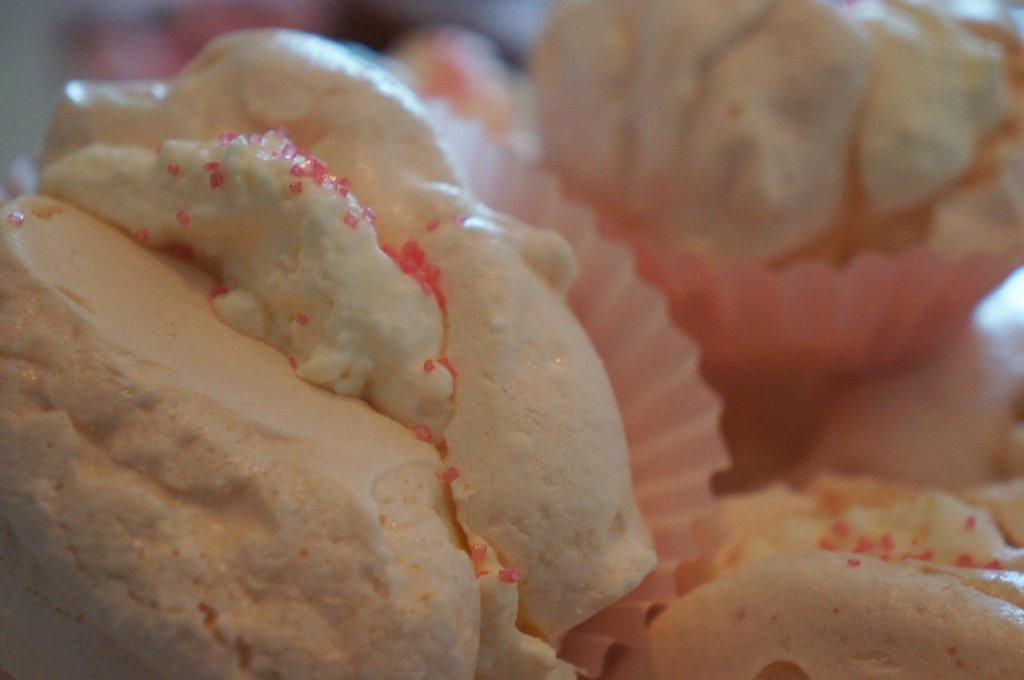What is the main subject of the image? There is a food item in the image. How are the food items arranged or presented? The food item is on cupcake liners. Can you describe the background of the image? The background of the image is blurred. What type of lace can be seen on the food item in the image? There is no lace present on the food item in the image. How much does the food item weigh on a scale in the image? There is no scale present in the image, so the weight of the food item cannot be determined. 